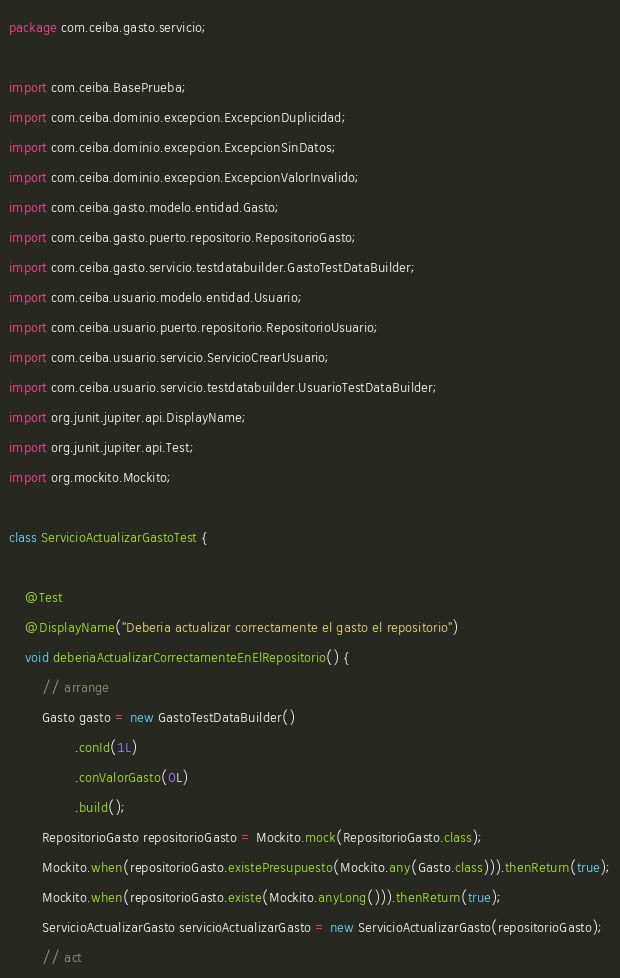<code> <loc_0><loc_0><loc_500><loc_500><_Java_>package com.ceiba.gasto.servicio;

import com.ceiba.BasePrueba;
import com.ceiba.dominio.excepcion.ExcepcionDuplicidad;
import com.ceiba.dominio.excepcion.ExcepcionSinDatos;
import com.ceiba.dominio.excepcion.ExcepcionValorInvalido;
import com.ceiba.gasto.modelo.entidad.Gasto;
import com.ceiba.gasto.puerto.repositorio.RepositorioGasto;
import com.ceiba.gasto.servicio.testdatabuilder.GastoTestDataBuilder;
import com.ceiba.usuario.modelo.entidad.Usuario;
import com.ceiba.usuario.puerto.repositorio.RepositorioUsuario;
import com.ceiba.usuario.servicio.ServicioCrearUsuario;
import com.ceiba.usuario.servicio.testdatabuilder.UsuarioTestDataBuilder;
import org.junit.jupiter.api.DisplayName;
import org.junit.jupiter.api.Test;
import org.mockito.Mockito;

class ServicioActualizarGastoTest {

    @Test
    @DisplayName("Deberia actualizar correctamente el gasto el repositorio")
    void deberiaActualizarCorrectamenteEnElRepositorio() {
        // arrange
        Gasto gasto = new GastoTestDataBuilder()
                .conId(1L)
                .conValorGasto(0L)
                .build();
        RepositorioGasto repositorioGasto = Mockito.mock(RepositorioGasto.class);
        Mockito.when(repositorioGasto.existePresupuesto(Mockito.any(Gasto.class))).thenReturn(true);
        Mockito.when(repositorioGasto.existe(Mockito.anyLong())).thenReturn(true);
        ServicioActualizarGasto servicioActualizarGasto = new ServicioActualizarGasto(repositorioGasto);
        // act</code> 